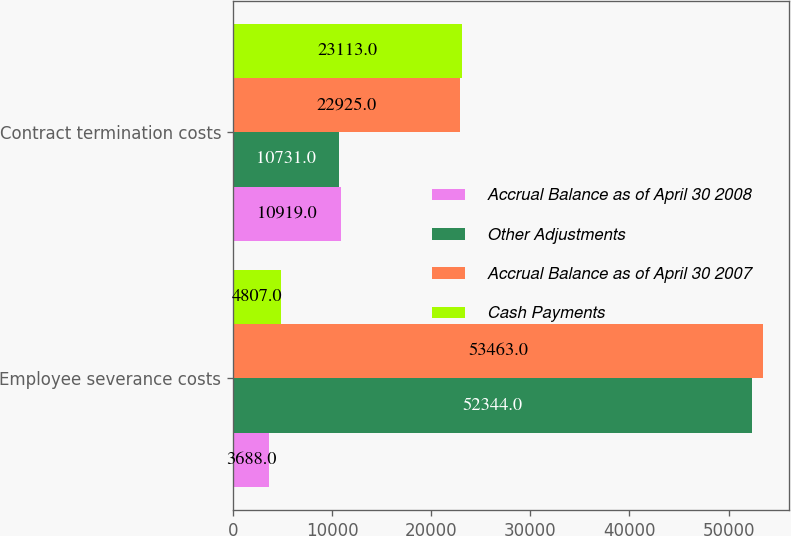Convert chart. <chart><loc_0><loc_0><loc_500><loc_500><stacked_bar_chart><ecel><fcel>Employee severance costs<fcel>Contract termination costs<nl><fcel>Accrual Balance as of April 30 2008<fcel>3688<fcel>10919<nl><fcel>Other Adjustments<fcel>52344<fcel>10731<nl><fcel>Accrual Balance as of April 30 2007<fcel>53463<fcel>22925<nl><fcel>Cash Payments<fcel>4807<fcel>23113<nl></chart> 